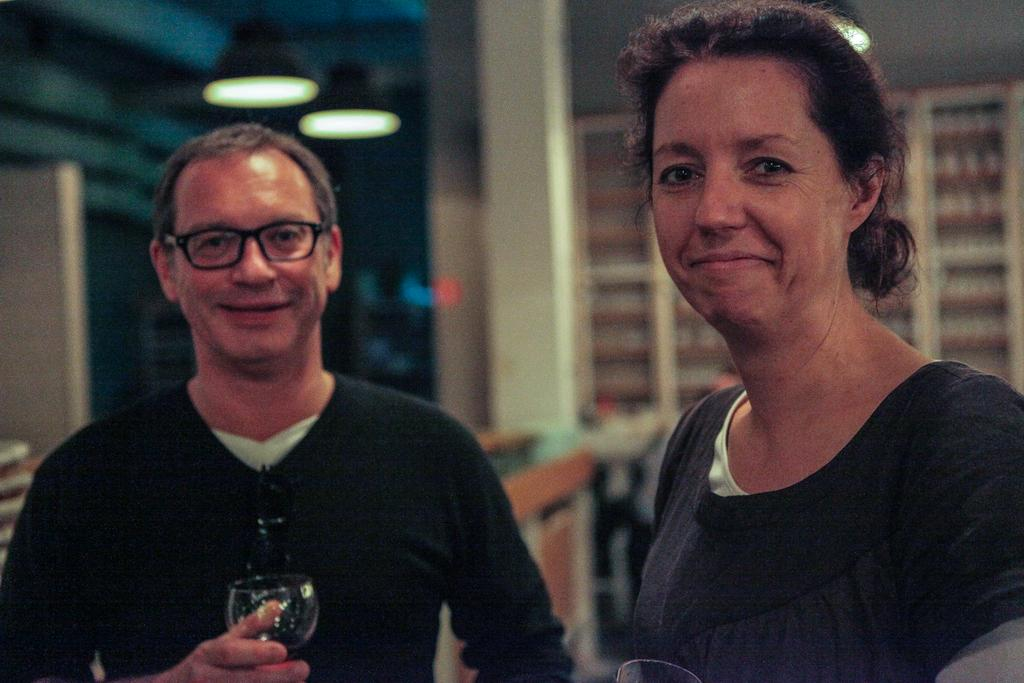How many people are in the image? There are two persons in the image. What is the man holding in the image? The man is holding a glass. What can be seen in the background of the image? There are racks and a light in the background of the image. What type of plantation is visible in the background of the image? There is no plantation visible in the background of the image. What type of polish is the man applying to the glass in the image? The man is not applying any polish to the glass in the image; he is simply holding it. 